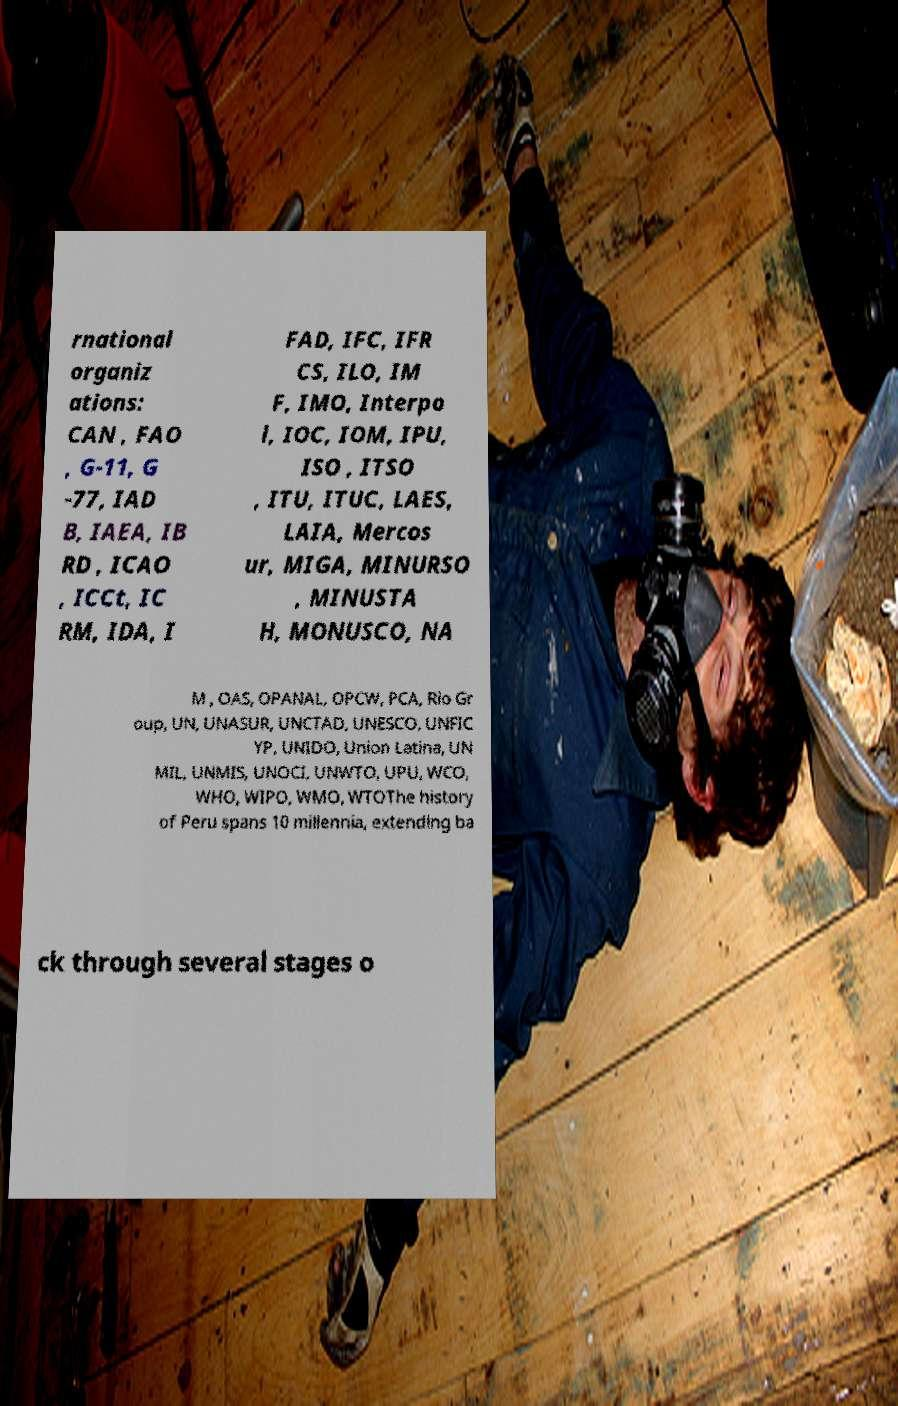What messages or text are displayed in this image? I need them in a readable, typed format. rnational organiz ations: CAN , FAO , G-11, G -77, IAD B, IAEA, IB RD , ICAO , ICCt, IC RM, IDA, I FAD, IFC, IFR CS, ILO, IM F, IMO, Interpo l, IOC, IOM, IPU, ISO , ITSO , ITU, ITUC, LAES, LAIA, Mercos ur, MIGA, MINURSO , MINUSTA H, MONUSCO, NA M , OAS, OPANAL, OPCW, PCA, Rio Gr oup, UN, UNASUR, UNCTAD, UNESCO, UNFIC YP, UNIDO, Union Latina, UN MIL, UNMIS, UNOCI, UNWTO, UPU, WCO, WHO, WIPO, WMO, WTOThe history of Peru spans 10 millennia, extending ba ck through several stages o 